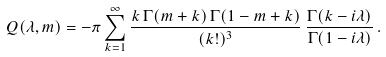Convert formula to latex. <formula><loc_0><loc_0><loc_500><loc_500>Q ( \lambda , m ) = - \pi \sum _ { k = 1 } ^ { \infty } { \frac { k \, \Gamma ( m + k ) \, \Gamma ( 1 - m + k ) } { ( k ! ) ^ { 3 } } } \, { \frac { \Gamma ( k - i \lambda ) } { \Gamma ( 1 - i \lambda ) } } \, .</formula> 